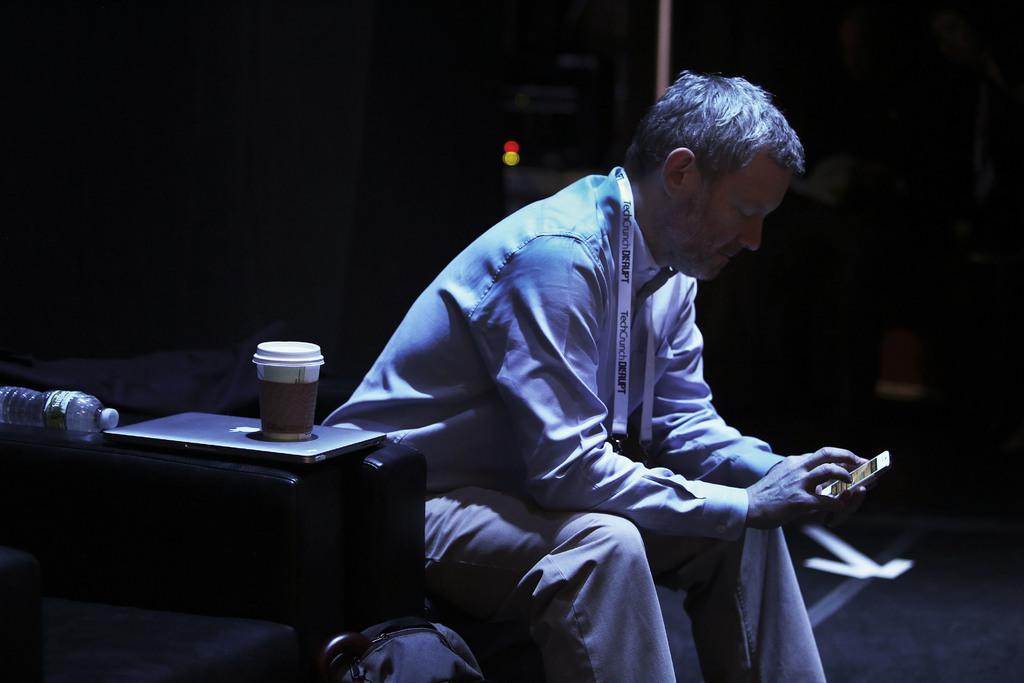In one or two sentences, can you explain what this image depicts? In this image there is one person is sitting as we can see in middle of this image is holding a mobile and there is a laptop is at left side of this image and there is a cup is kept on to this laptop and there is a bag at bottom of this image. There is a bottle at left side of this image. 